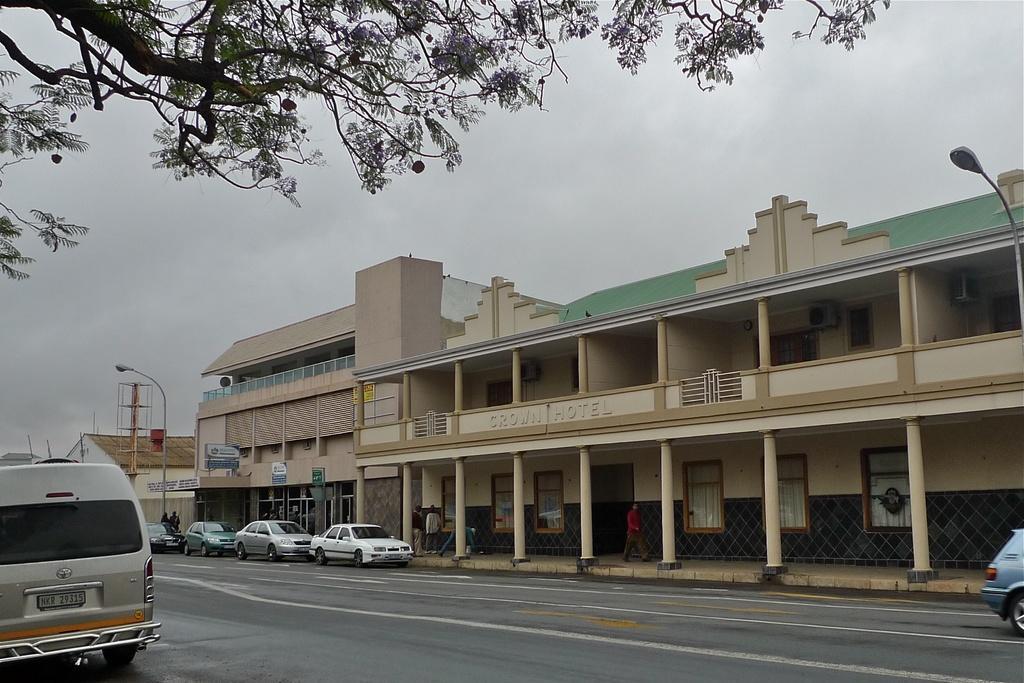Please provide a concise description of this image. In this picture I can see buildings and couple of pole lights and few cars on the road and I can see few people walking and a board with some text and I can see text on the wall of the building and I can see tree branches with leaves and a cloudy sky. 